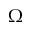Convert formula to latex. <formula><loc_0><loc_0><loc_500><loc_500>\Omega</formula> 